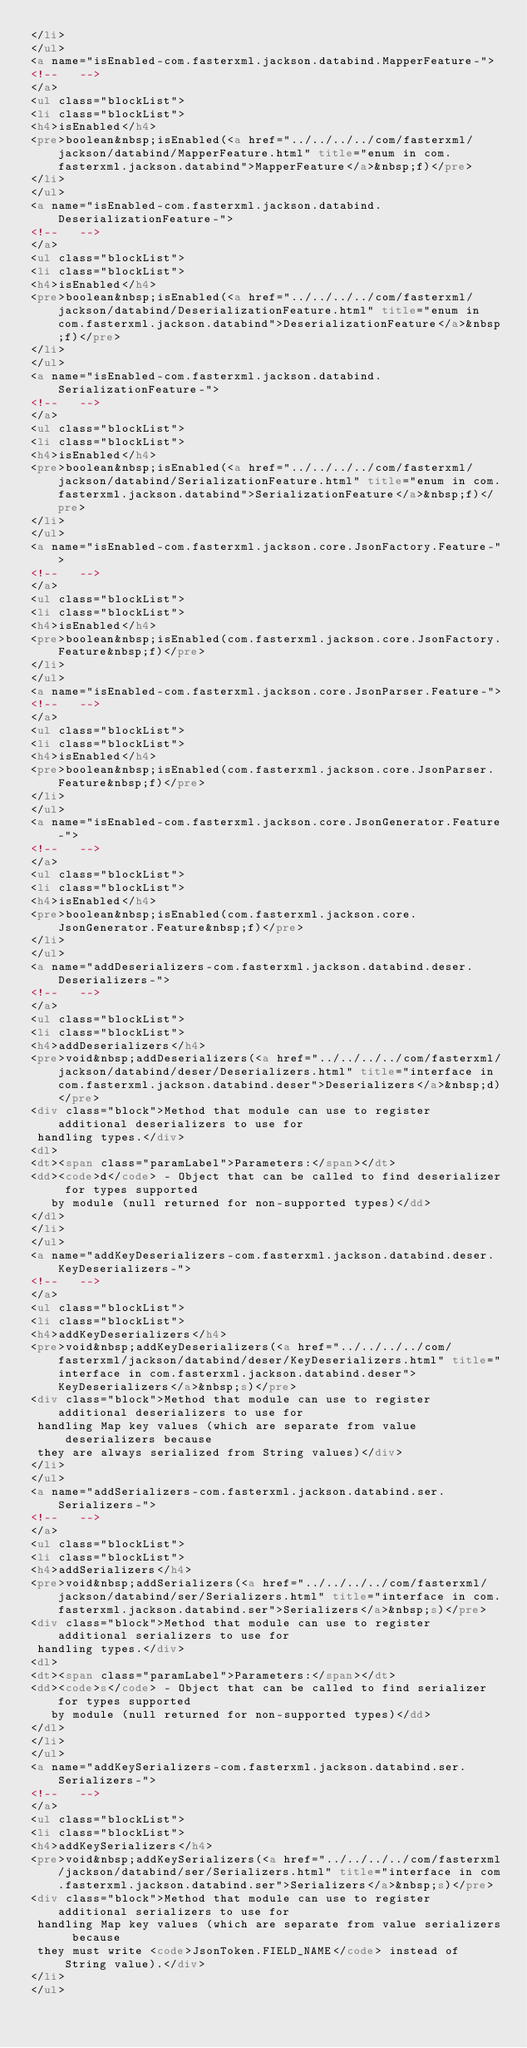<code> <loc_0><loc_0><loc_500><loc_500><_HTML_></li>
</ul>
<a name="isEnabled-com.fasterxml.jackson.databind.MapperFeature-">
<!--   -->
</a>
<ul class="blockList">
<li class="blockList">
<h4>isEnabled</h4>
<pre>boolean&nbsp;isEnabled(<a href="../../../../com/fasterxml/jackson/databind/MapperFeature.html" title="enum in com.fasterxml.jackson.databind">MapperFeature</a>&nbsp;f)</pre>
</li>
</ul>
<a name="isEnabled-com.fasterxml.jackson.databind.DeserializationFeature-">
<!--   -->
</a>
<ul class="blockList">
<li class="blockList">
<h4>isEnabled</h4>
<pre>boolean&nbsp;isEnabled(<a href="../../../../com/fasterxml/jackson/databind/DeserializationFeature.html" title="enum in com.fasterxml.jackson.databind">DeserializationFeature</a>&nbsp;f)</pre>
</li>
</ul>
<a name="isEnabled-com.fasterxml.jackson.databind.SerializationFeature-">
<!--   -->
</a>
<ul class="blockList">
<li class="blockList">
<h4>isEnabled</h4>
<pre>boolean&nbsp;isEnabled(<a href="../../../../com/fasterxml/jackson/databind/SerializationFeature.html" title="enum in com.fasterxml.jackson.databind">SerializationFeature</a>&nbsp;f)</pre>
</li>
</ul>
<a name="isEnabled-com.fasterxml.jackson.core.JsonFactory.Feature-">
<!--   -->
</a>
<ul class="blockList">
<li class="blockList">
<h4>isEnabled</h4>
<pre>boolean&nbsp;isEnabled(com.fasterxml.jackson.core.JsonFactory.Feature&nbsp;f)</pre>
</li>
</ul>
<a name="isEnabled-com.fasterxml.jackson.core.JsonParser.Feature-">
<!--   -->
</a>
<ul class="blockList">
<li class="blockList">
<h4>isEnabled</h4>
<pre>boolean&nbsp;isEnabled(com.fasterxml.jackson.core.JsonParser.Feature&nbsp;f)</pre>
</li>
</ul>
<a name="isEnabled-com.fasterxml.jackson.core.JsonGenerator.Feature-">
<!--   -->
</a>
<ul class="blockList">
<li class="blockList">
<h4>isEnabled</h4>
<pre>boolean&nbsp;isEnabled(com.fasterxml.jackson.core.JsonGenerator.Feature&nbsp;f)</pre>
</li>
</ul>
<a name="addDeserializers-com.fasterxml.jackson.databind.deser.Deserializers-">
<!--   -->
</a>
<ul class="blockList">
<li class="blockList">
<h4>addDeserializers</h4>
<pre>void&nbsp;addDeserializers(<a href="../../../../com/fasterxml/jackson/databind/deser/Deserializers.html" title="interface in com.fasterxml.jackson.databind.deser">Deserializers</a>&nbsp;d)</pre>
<div class="block">Method that module can use to register additional deserializers to use for
 handling types.</div>
<dl>
<dt><span class="paramLabel">Parameters:</span></dt>
<dd><code>d</code> - Object that can be called to find deserializer for types supported
   by module (null returned for non-supported types)</dd>
</dl>
</li>
</ul>
<a name="addKeyDeserializers-com.fasterxml.jackson.databind.deser.KeyDeserializers-">
<!--   -->
</a>
<ul class="blockList">
<li class="blockList">
<h4>addKeyDeserializers</h4>
<pre>void&nbsp;addKeyDeserializers(<a href="../../../../com/fasterxml/jackson/databind/deser/KeyDeserializers.html" title="interface in com.fasterxml.jackson.databind.deser">KeyDeserializers</a>&nbsp;s)</pre>
<div class="block">Method that module can use to register additional deserializers to use for
 handling Map key values (which are separate from value deserializers because
 they are always serialized from String values)</div>
</li>
</ul>
<a name="addSerializers-com.fasterxml.jackson.databind.ser.Serializers-">
<!--   -->
</a>
<ul class="blockList">
<li class="blockList">
<h4>addSerializers</h4>
<pre>void&nbsp;addSerializers(<a href="../../../../com/fasterxml/jackson/databind/ser/Serializers.html" title="interface in com.fasterxml.jackson.databind.ser">Serializers</a>&nbsp;s)</pre>
<div class="block">Method that module can use to register additional serializers to use for
 handling types.</div>
<dl>
<dt><span class="paramLabel">Parameters:</span></dt>
<dd><code>s</code> - Object that can be called to find serializer for types supported
   by module (null returned for non-supported types)</dd>
</dl>
</li>
</ul>
<a name="addKeySerializers-com.fasterxml.jackson.databind.ser.Serializers-">
<!--   -->
</a>
<ul class="blockList">
<li class="blockList">
<h4>addKeySerializers</h4>
<pre>void&nbsp;addKeySerializers(<a href="../../../../com/fasterxml/jackson/databind/ser/Serializers.html" title="interface in com.fasterxml.jackson.databind.ser">Serializers</a>&nbsp;s)</pre>
<div class="block">Method that module can use to register additional serializers to use for
 handling Map key values (which are separate from value serializers because
 they must write <code>JsonToken.FIELD_NAME</code> instead of String value).</div>
</li>
</ul></code> 